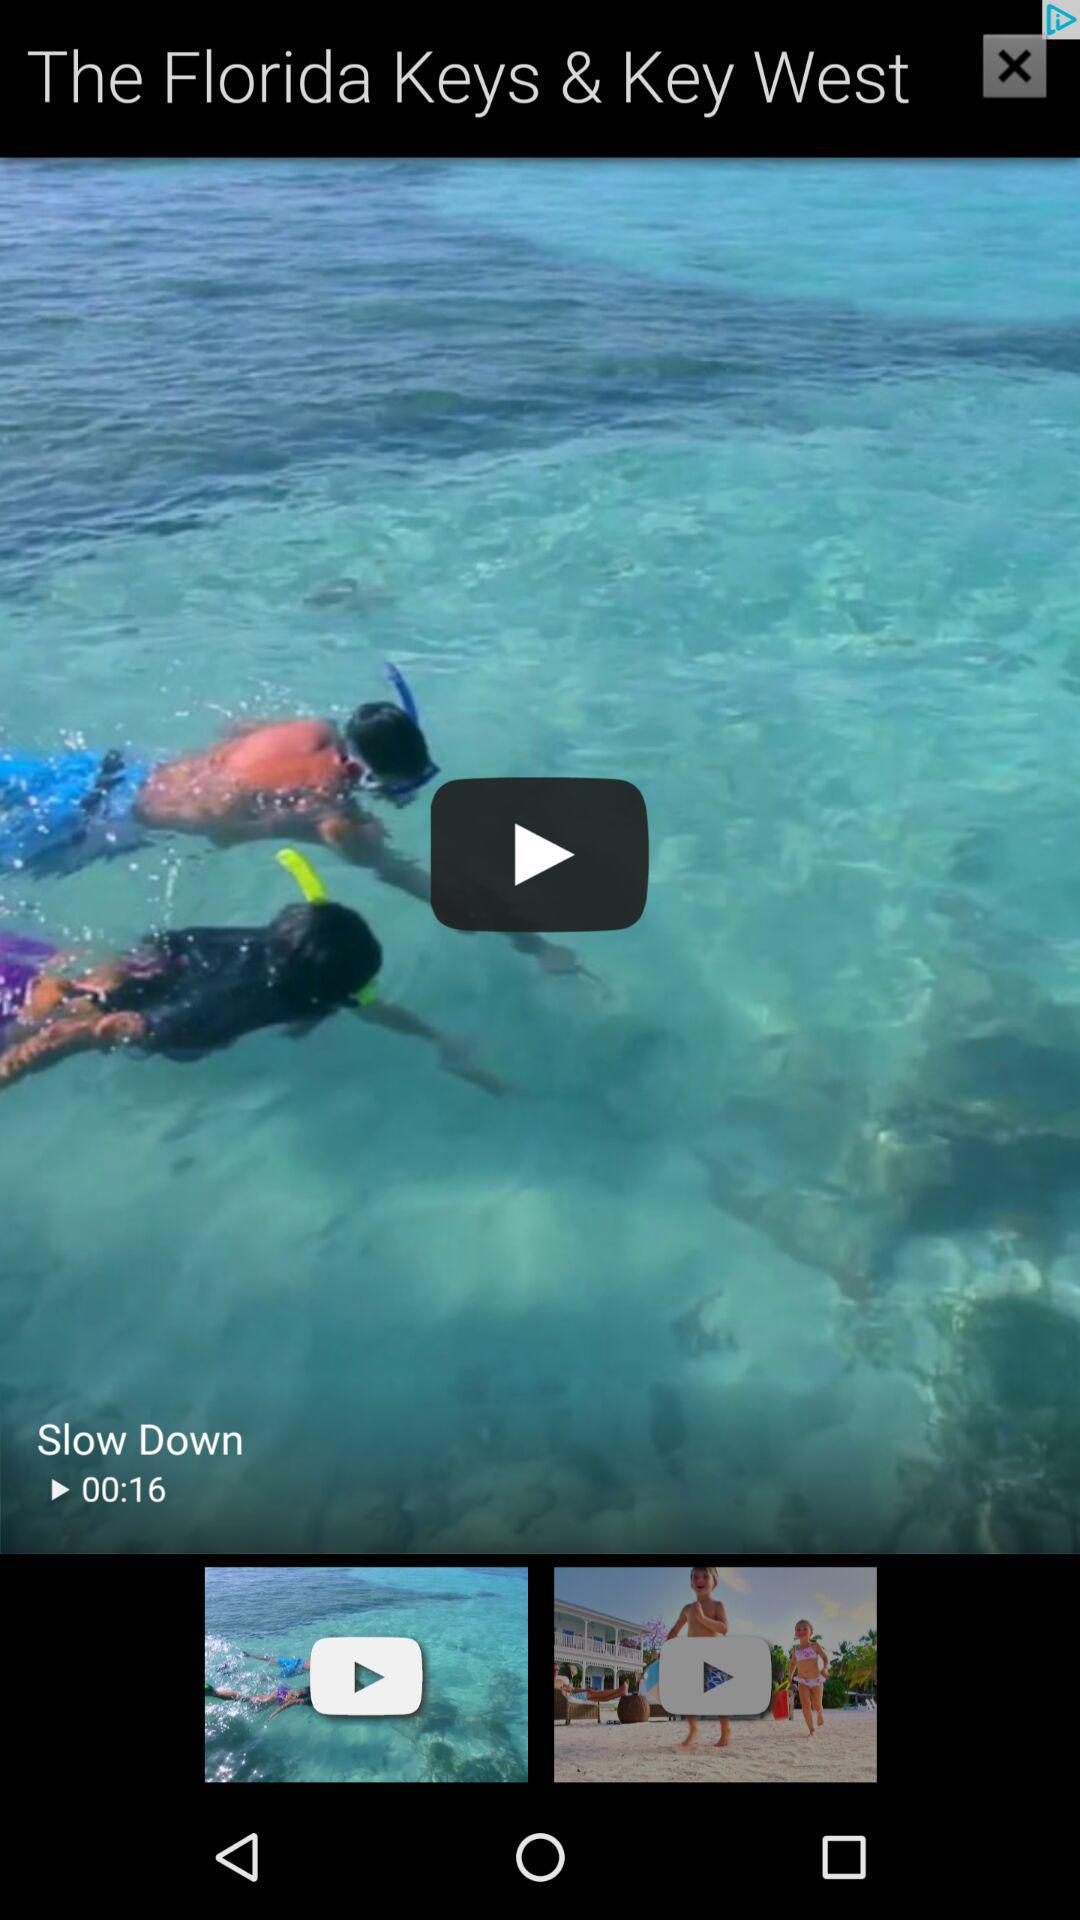Who posted "Slow Down"?
When the provided information is insufficient, respond with <no answer>. <no answer> 